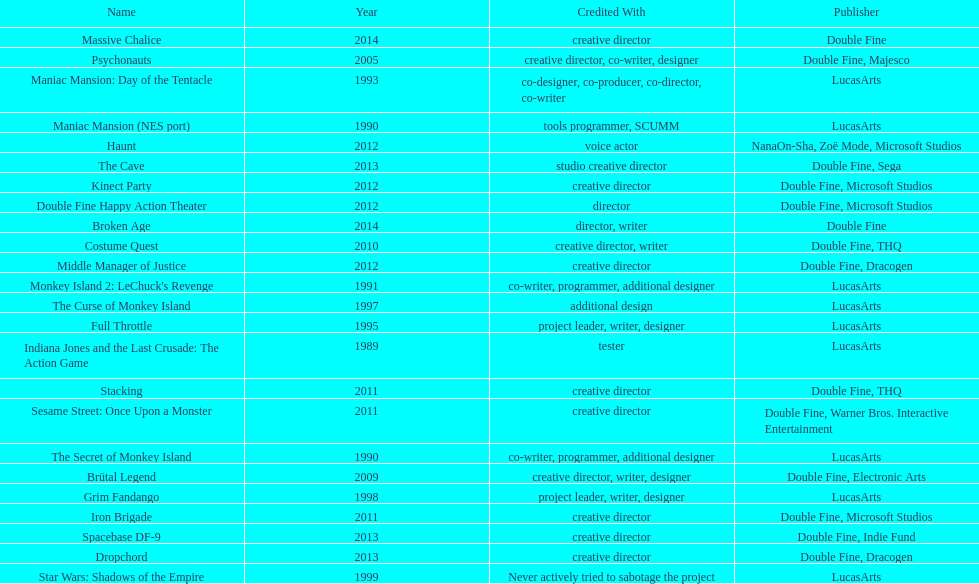How many games were credited with a creative director? 11. 